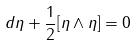Convert formula to latex. <formula><loc_0><loc_0><loc_500><loc_500>d \eta + \frac { 1 } { 2 } [ \eta \wedge \eta ] = 0</formula> 